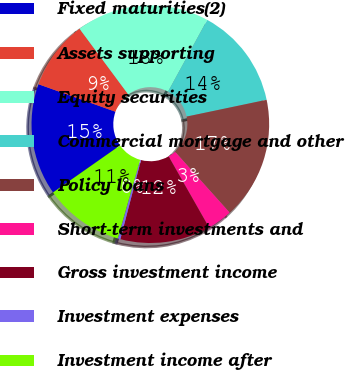Convert chart to OTSL. <chart><loc_0><loc_0><loc_500><loc_500><pie_chart><fcel>Fixed maturities(2)<fcel>Assets supporting<fcel>Equity securities<fcel>Commercial mortgage and other<fcel>Policy loans<fcel>Short-term investments and<fcel>Gross investment income<fcel>Investment expenses<fcel>Investment income after<nl><fcel>15.2%<fcel>9.38%<fcel>18.11%<fcel>13.75%<fcel>16.66%<fcel>3.4%<fcel>12.29%<fcel>0.36%<fcel>10.84%<nl></chart> 